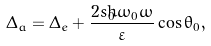<formula> <loc_0><loc_0><loc_500><loc_500>\Delta _ { a } = \Delta _ { e } + \frac { 2 s _ { 0 } \hbar { \omega } _ { 0 } \omega } \varepsilon \cos \theta _ { 0 } ,</formula> 